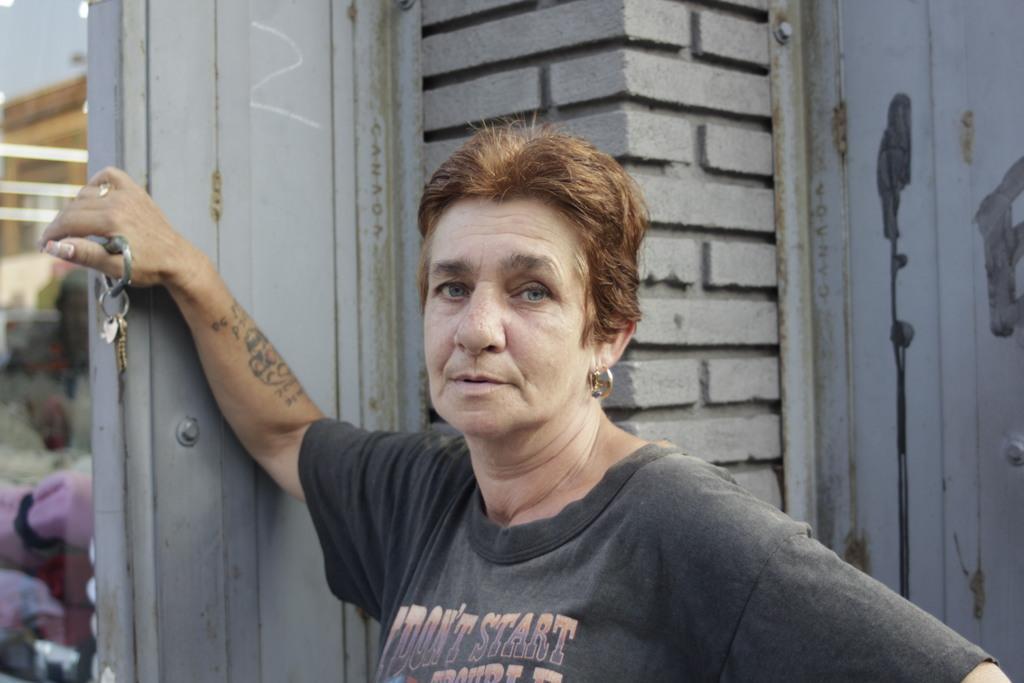Can you describe this image briefly? In this image I can see a person is standing and holding the keys. Back I can see the ash color wall. 